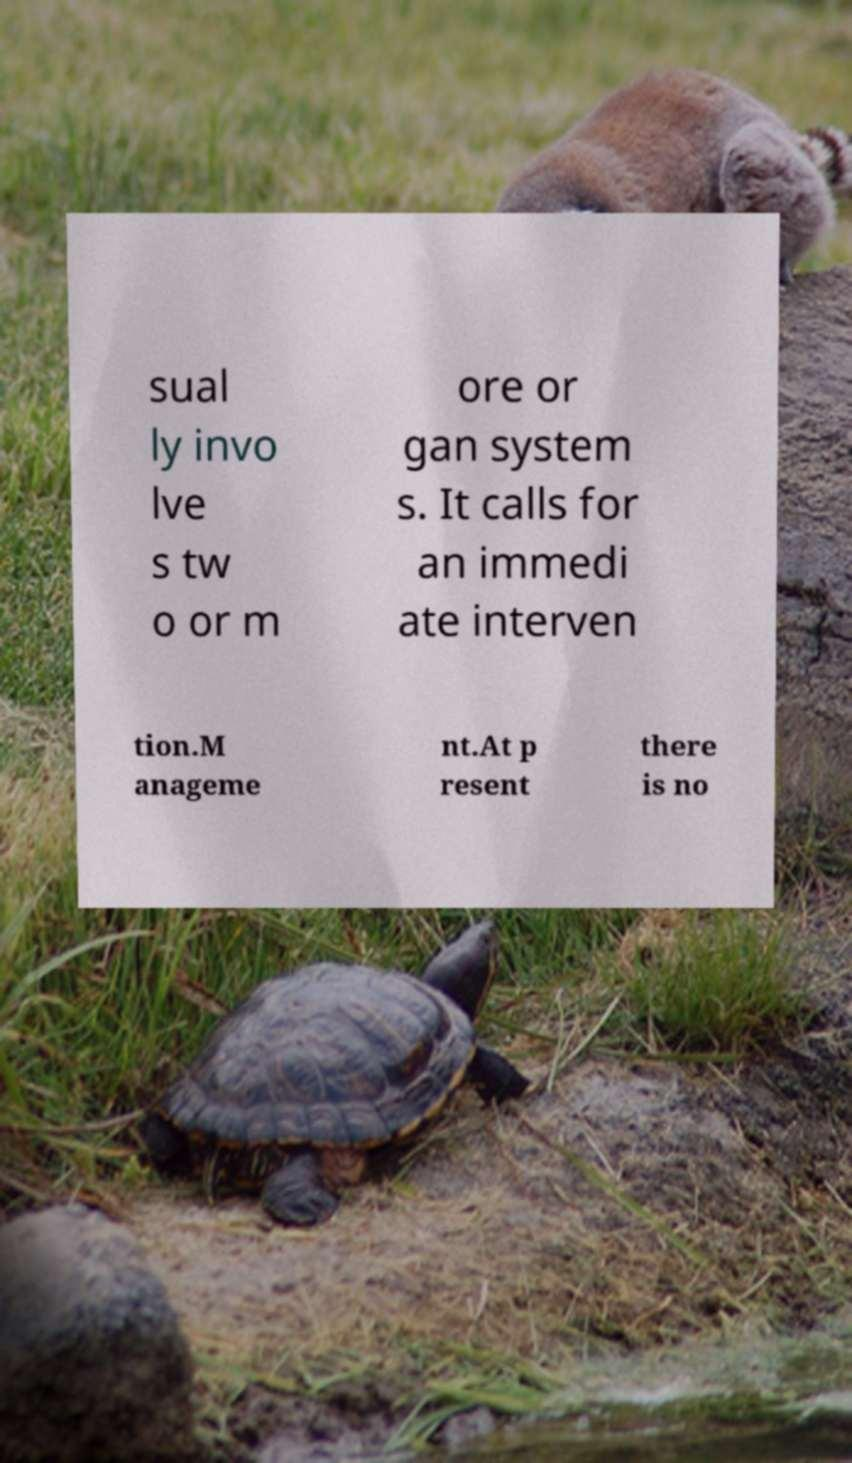Could you extract and type out the text from this image? sual ly invo lve s tw o or m ore or gan system s. It calls for an immedi ate interven tion.M anageme nt.At p resent there is no 